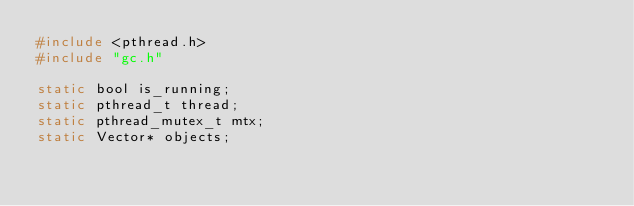<code> <loc_0><loc_0><loc_500><loc_500><_C_>#include <pthread.h>
#include "gc.h"

static bool is_running;
static pthread_t thread;
static pthread_mutex_t mtx;
static Vector* objects;
</code> 